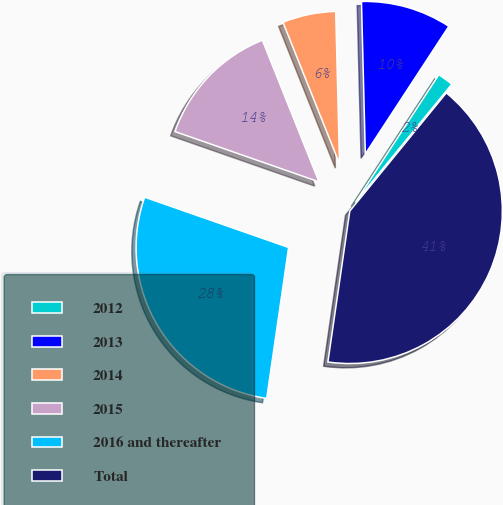Convert chart to OTSL. <chart><loc_0><loc_0><loc_500><loc_500><pie_chart><fcel>2012<fcel>2013<fcel>2014<fcel>2015<fcel>2016 and thereafter<fcel>Total<nl><fcel>1.68%<fcel>9.62%<fcel>5.65%<fcel>13.6%<fcel>28.05%<fcel>41.39%<nl></chart> 